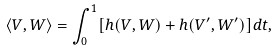Convert formula to latex. <formula><loc_0><loc_0><loc_500><loc_500>\langle V , W \rangle = \int ^ { 1 } _ { 0 } [ h ( V , W ) + h ( V ^ { \prime } , W ^ { \prime } ) ] d t ,</formula> 